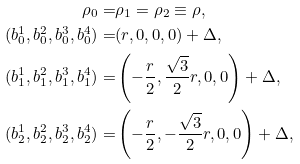<formula> <loc_0><loc_0><loc_500><loc_500>\rho _ { 0 } = & \rho _ { 1 } = \rho _ { 2 } \equiv \rho , \\ ( b _ { 0 } ^ { 1 } , b _ { 0 } ^ { 2 } , b _ { 0 } ^ { 3 } , b _ { 0 } ^ { 4 } ) = & ( r , 0 , 0 , 0 ) + \Delta , \\ ( b _ { 1 } ^ { 1 } , b _ { 1 } ^ { 2 } , b _ { 1 } ^ { 3 } , b _ { 1 } ^ { 4 } ) = & \left ( - \frac { r } { 2 } , \frac { \sqrt { 3 } } { 2 } r , 0 , 0 \right ) + \Delta , \\ ( b _ { 2 } ^ { 1 } , b _ { 2 } ^ { 2 } , b _ { 2 } ^ { 3 } , b _ { 2 } ^ { 4 } ) = & \left ( - \frac { r } { 2 } , - \frac { \sqrt { 3 } } { 2 } r , 0 , 0 \right ) + \Delta ,</formula> 